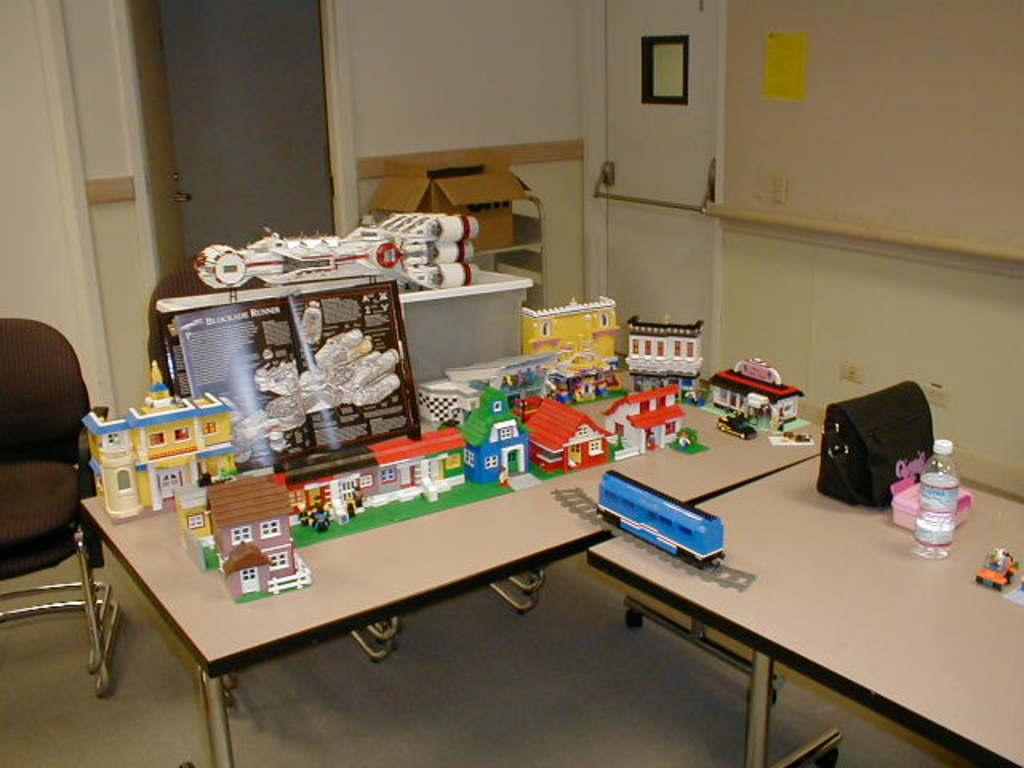What objects are on the table in the image? There are toys on a table in the image. What piece of furniture is located beside the table? There is a chair beside the table in the image. How many doors can be seen in the background of the image? There are two doors in the background of the image. What type of clam is sitting on the chair in the image? There is no clam present in the image; the chair is empty. What does the person in the image desire? There is no person present in the image, so it is impossible to determine their desires. 